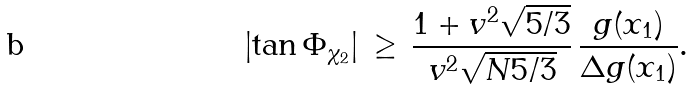<formula> <loc_0><loc_0><loc_500><loc_500>\left | \tan \Phi _ { \chi _ { 2 } } \right | \, \geq \, { \frac { 1 + v ^ { 2 } \sqrt { 5 / 3 } } { v ^ { 2 } \sqrt { N 5 / 3 } } } \, { \frac { g ( x _ { 1 } ) } { \Delta g ( x _ { 1 } ) } } .</formula> 